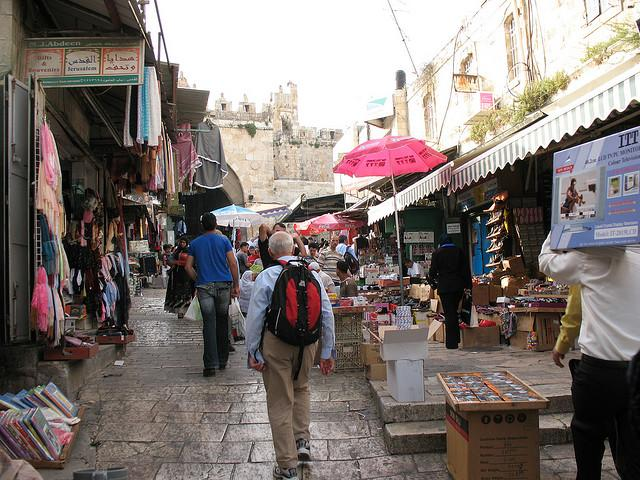What are the people walking through this area looking to do?

Choices:
A) paint
B) shop
C) investigate
D) race shop 